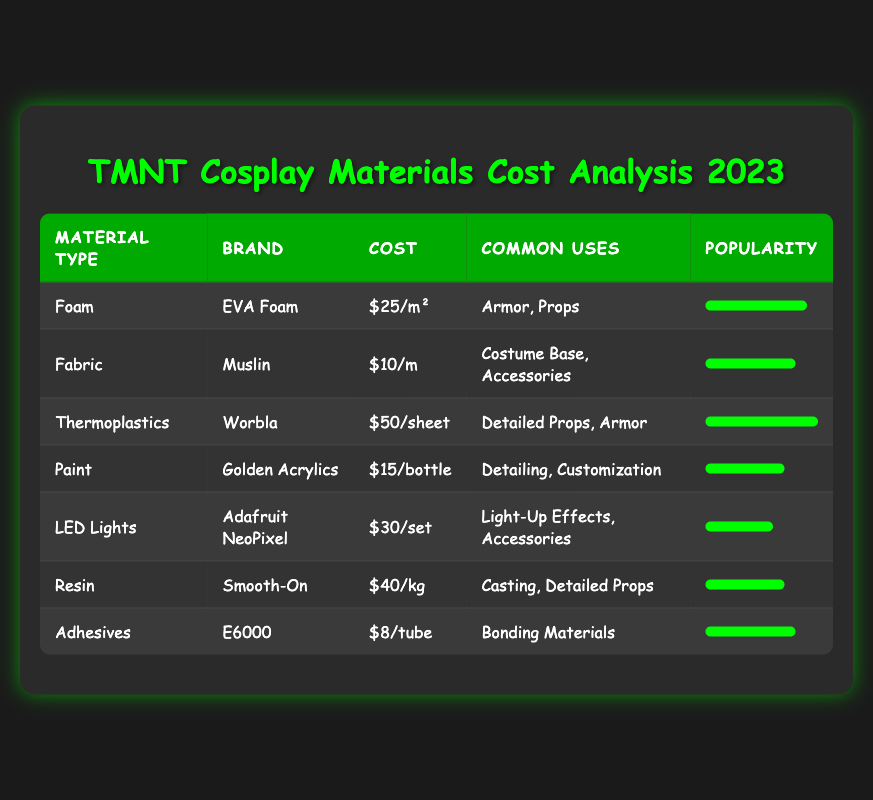What is the cost per square meter of Foam? From the table, under the "Foam" entry, the "Cost" is listed as $25/m².
Answer: $25/m² Which material has the highest popularity score? Looking at the "Popularity" column, the material "Worbla" has a score of 10, which is the highest among all the materials listed.
Answer: Worbla What is the total cost of purchasing one square meter of Fabric and one bottle of Paint? For Fabric, the cost is $10/m and for Paint, the cost is $15/bottle. Adding them together: 10 + 15 = 25.
Answer: $25 Is the cost of LED Lights more than $25? The cost of LED Lights is $30/set, which is greater than $25.
Answer: Yes What is the average cost per item type based on the provided costs for Foam, Fabric, and Thermoplastics? The costs are $25 for Foam, $10 for Fabric, and $50 for Thermoplastics. The sum is 25 + 10 + 50 = 85. There are 3 items, so the average is 85/3 = 28.33.
Answer: $28.33 Which material is used primarily for detailing and customization? The table states that "Golden Acrylics" under the Paint category is used for detailing and customization, as listed in the "Common Uses" column.
Answer: Golden Acrylics If you wanted to purchase materials for 3 armor costumes using Foam and Worbla, how much would you spend? For 3 square meters of Foam, the cost is 3 * 25 = 75. For 3 sheets of Worbla, the cost is 3 * 50 = 150. Adding them up: 75 + 150 = 225.
Answer: $225 How does the cost of Adhesives compare to the cost of Fabric? Adhesives cost $8/tube while Fabric costs $10/m. Since $8 is less than $10, Adhesives are cheaper than Fabric.
Answer: Cheaper What materials have a popularity score higher than 7? The materials with scores higher than 7 are Foam (9), Worbla (10), and Adhesives (8). These can be found by scanning the "Popularity Score" column for values greater than 7.
Answer: Foam, Worbla, Adhesives 